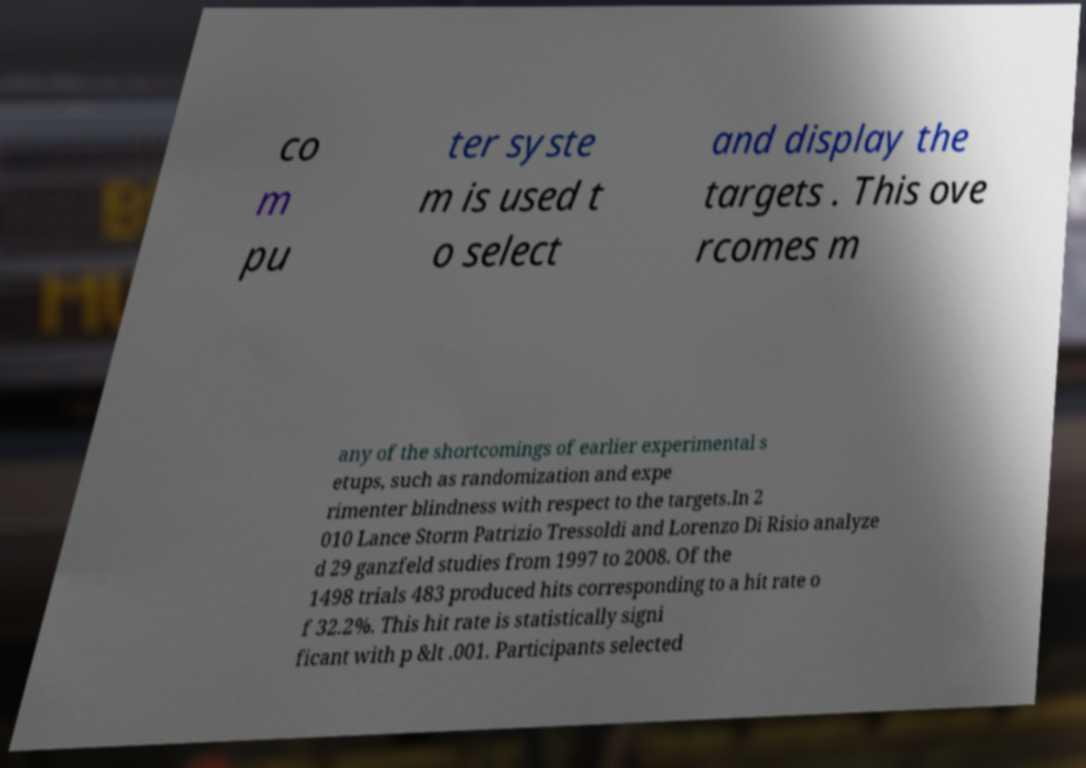Can you accurately transcribe the text from the provided image for me? co m pu ter syste m is used t o select and display the targets . This ove rcomes m any of the shortcomings of earlier experimental s etups, such as randomization and expe rimenter blindness with respect to the targets.In 2 010 Lance Storm Patrizio Tressoldi and Lorenzo Di Risio analyze d 29 ganzfeld studies from 1997 to 2008. Of the 1498 trials 483 produced hits corresponding to a hit rate o f 32.2%. This hit rate is statistically signi ficant with p &lt .001. Participants selected 